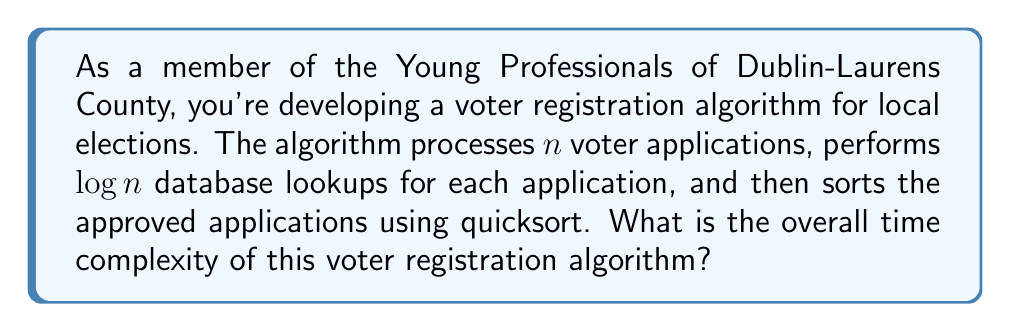Provide a solution to this math problem. Let's break down the algorithm and analyze each step:

1. Processing $n$ voter applications:
   This step involves iterating through all applications, which takes $O(n)$ time.

2. Performing $\log n$ database lookups for each application:
   For each of the $n$ applications, we perform $\log n$ lookups.
   This results in a time complexity of $O(n \log n)$.

3. Sorting approved applications using quicksort:
   Quicksort has an average-case time complexity of $O(m \log m)$, where $m$ is the number of items being sorted.
   In the worst case, all $n$ applications could be approved, so we consider $m = n$.
   Therefore, the sorting step has a time complexity of $O(n \log n)$.

To determine the overall time complexity, we add up the complexities of each step:

$$ O(n) + O(n \log n) + O(n \log n) $$

Simplifying this expression:

$$ O(n) + O(n \log n) + O(n \log n) = O(n + 2n \log n) = O(n \log n) $$

We can drop the constant factor 2 and the lower-order term $n$, as they don't affect the asymptotic complexity.

Therefore, the overall time complexity of the voter registration algorithm is $O(n \log n)$.
Answer: $O(n \log n)$ 